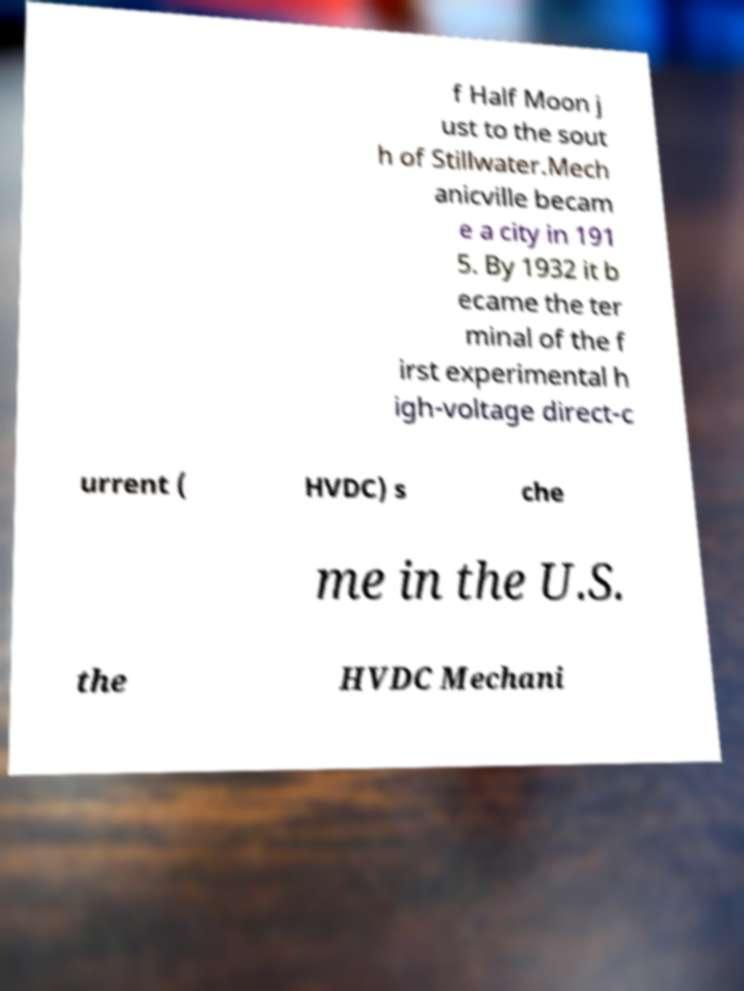There's text embedded in this image that I need extracted. Can you transcribe it verbatim? f Half Moon j ust to the sout h of Stillwater.Mech anicville becam e a city in 191 5. By 1932 it b ecame the ter minal of the f irst experimental h igh-voltage direct-c urrent ( HVDC) s che me in the U.S. the HVDC Mechani 